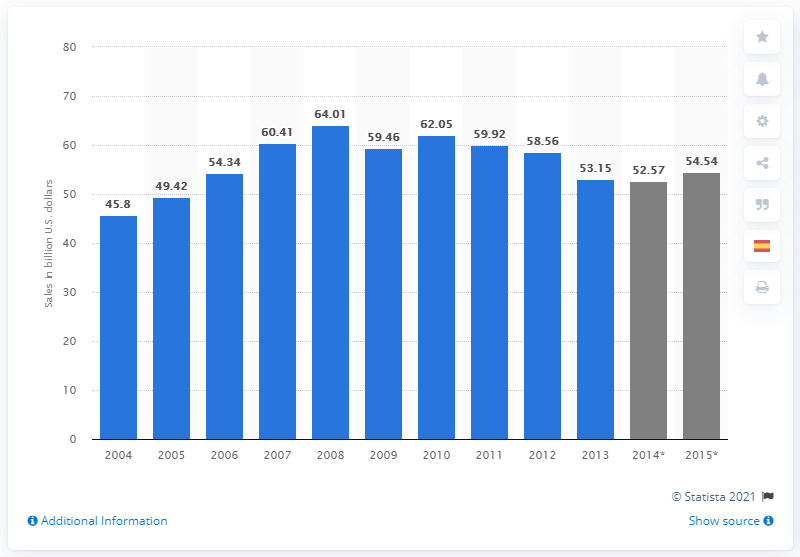Point out several critical features in this image. The U.S. aerospace industry sold military aircraft worth $59.92 billion in dollars in 2010. 